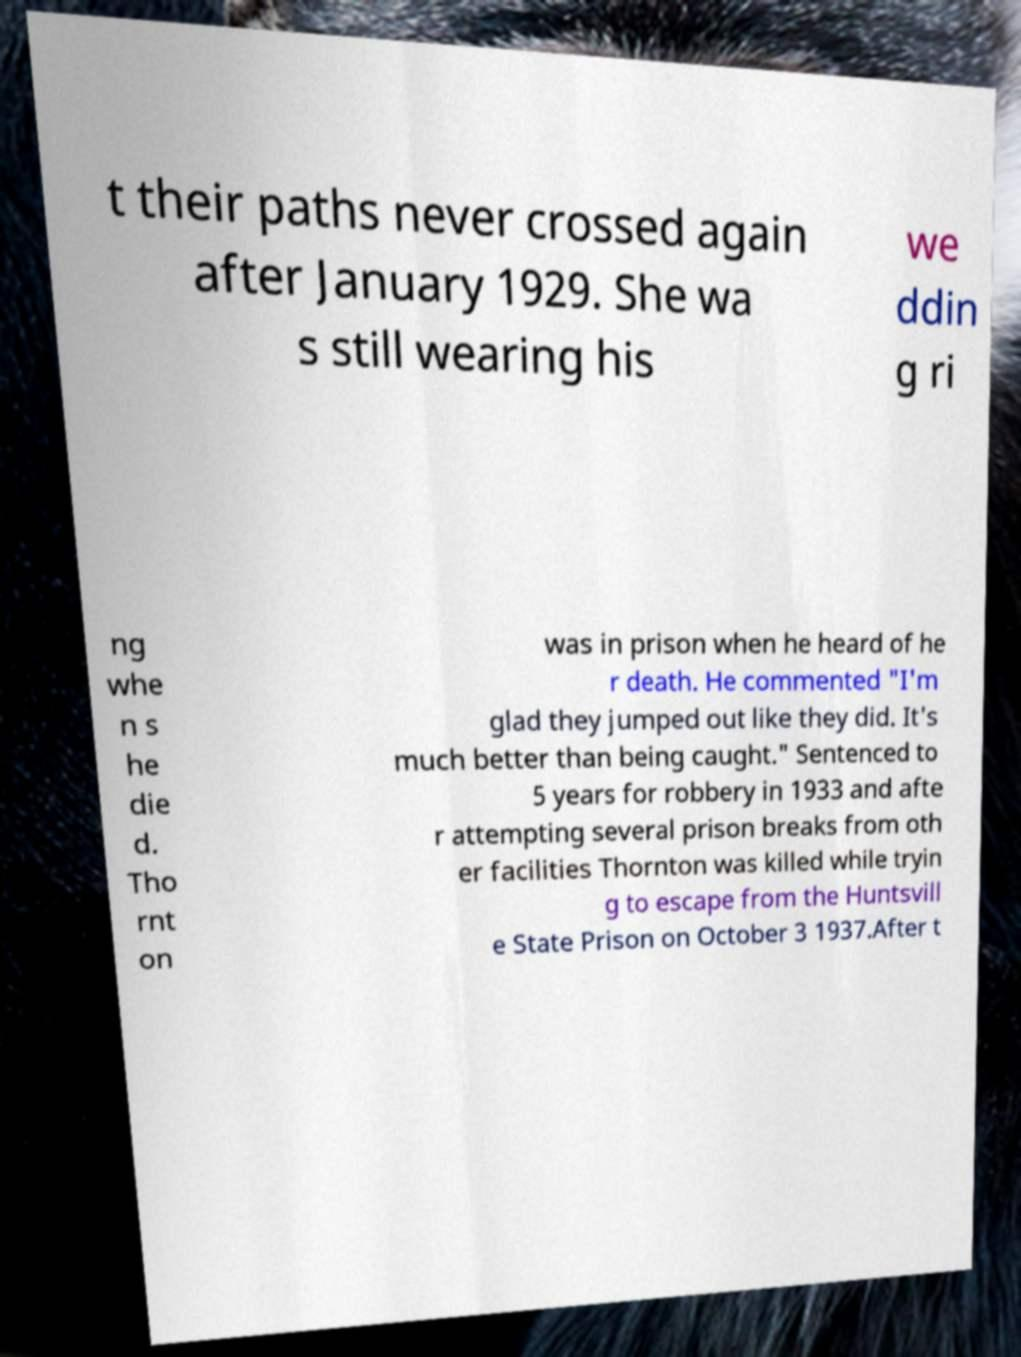Can you accurately transcribe the text from the provided image for me? t their paths never crossed again after January 1929. She wa s still wearing his we ddin g ri ng whe n s he die d. Tho rnt on was in prison when he heard of he r death. He commented "I'm glad they jumped out like they did. It's much better than being caught." Sentenced to 5 years for robbery in 1933 and afte r attempting several prison breaks from oth er facilities Thornton was killed while tryin g to escape from the Huntsvill e State Prison on October 3 1937.After t 